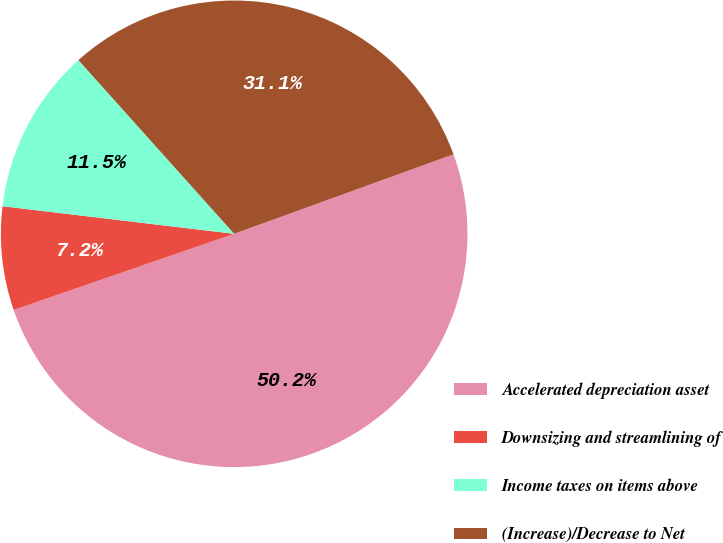<chart> <loc_0><loc_0><loc_500><loc_500><pie_chart><fcel>Accelerated depreciation asset<fcel>Downsizing and streamlining of<fcel>Income taxes on items above<fcel>(Increase)/Decrease to Net<nl><fcel>50.24%<fcel>7.18%<fcel>11.48%<fcel>31.1%<nl></chart> 